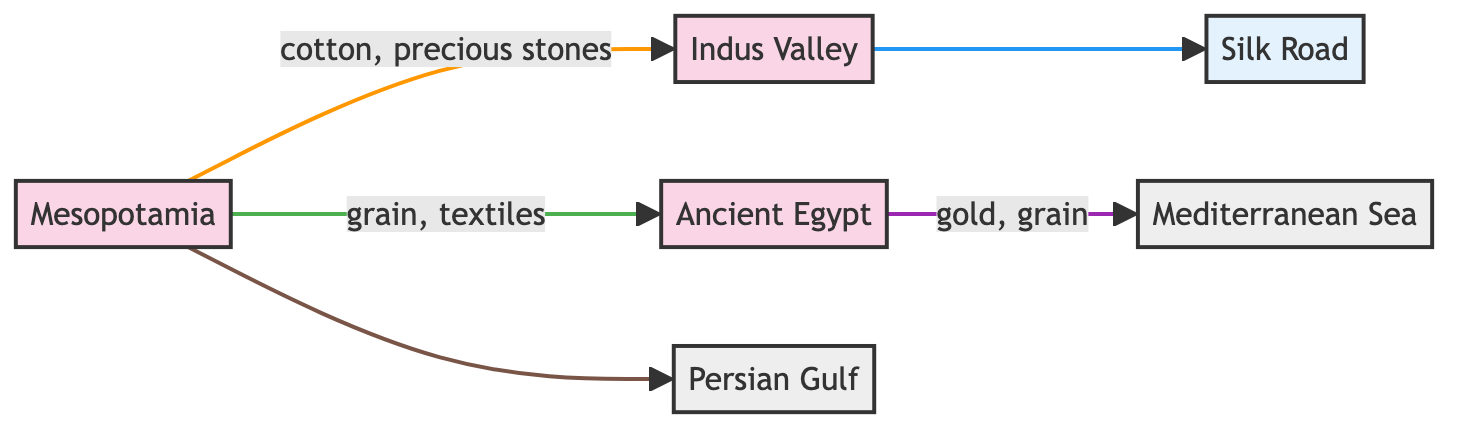What are the main goods traded between Mesopotamia and the Indus Valley? According to the diagram, Mesopotamia trades cotton and precious stones with the Indus Valley. These goods are specified on the edge connecting the two nodes.
Answer: cotton, precious stones How many civilizations are represented in the diagram? The diagram contains three civilizations: Mesopotamia, Indus Valley, and Ancient Egypt. By counting the nodes of type "civilization," we find a total of three.
Answer: 3 Which civilization connects to the Silk Road? The edge connecting the Indus Valley to the Silk Road shows that the relationship is "connects." Therefore, the Indus Valley is the civilization that connects to the Silk Road.
Answer: Indus Valley What goods are traded between Ancient Egypt and the Mediterranean Sea? The diagram indicates that Ancient Egypt trades gold and grain with the Mediterranean Sea. This is clearly stated on the edge connecting these two nodes in the diagram.
Answer: gold, grain How many edges are there in total in the diagram? By examining the connections (edges) between the nodes, we can count a total of five edges represented in the diagram, linking the various nodes.
Answer: 5 What type of route connects Mesopotamia to the Persian Gulf? The relationship between Mesopotamia and the Persian Gulf is "access to," which specifies the nature of the connection as it relies on waterways.
Answer: waterways Which civilization does Mesopotamia trade grain with? Mesopotamia trades grain with Ancient Egypt, as shown in the edge linking these two civilizations in the diagram.
Answer: Ancient Egypt What are the two natural features included in the graph? The diagram includes two natural features: the Mediterranean Sea and the Persian Gulf. They are represented as types of nodes distinct from civilizations and trade routes.
Answer: Mediterranean Sea, Persian Gulf Which goods are traded along the overland route from Mesopotamia to the Indus Valley? The edge illustrates that the goods traded along the overland route from Mesopotamia to the Indus Valley include cotton and precious stones, as listed on that connection.
Answer: cotton, precious stones 